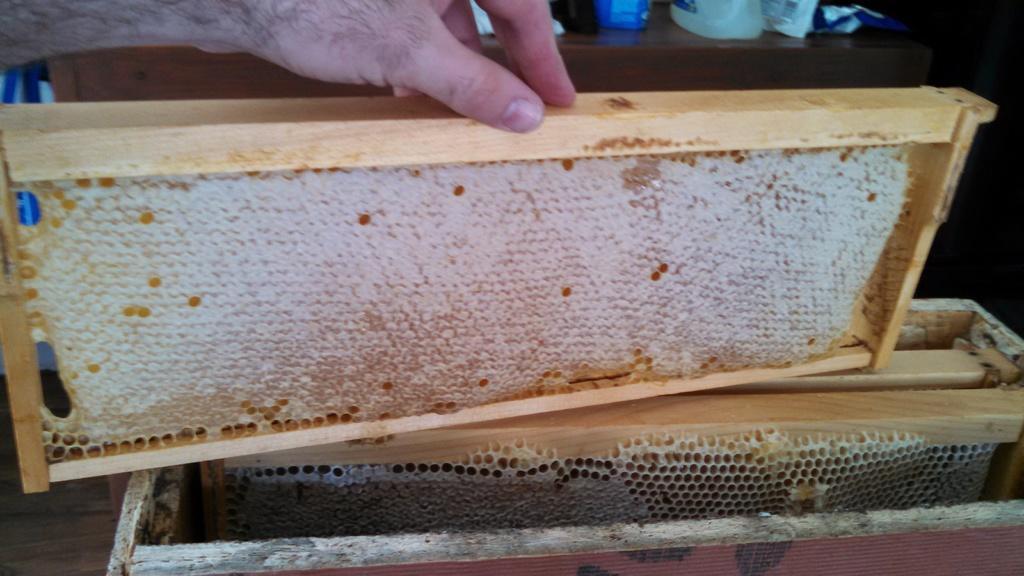In one or two sentences, can you explain what this image depicts? In the foreground of this image, there is honey comb to the wooden structure which is holding by a person's hand. In the background, there are few objects on the wooden surface. 